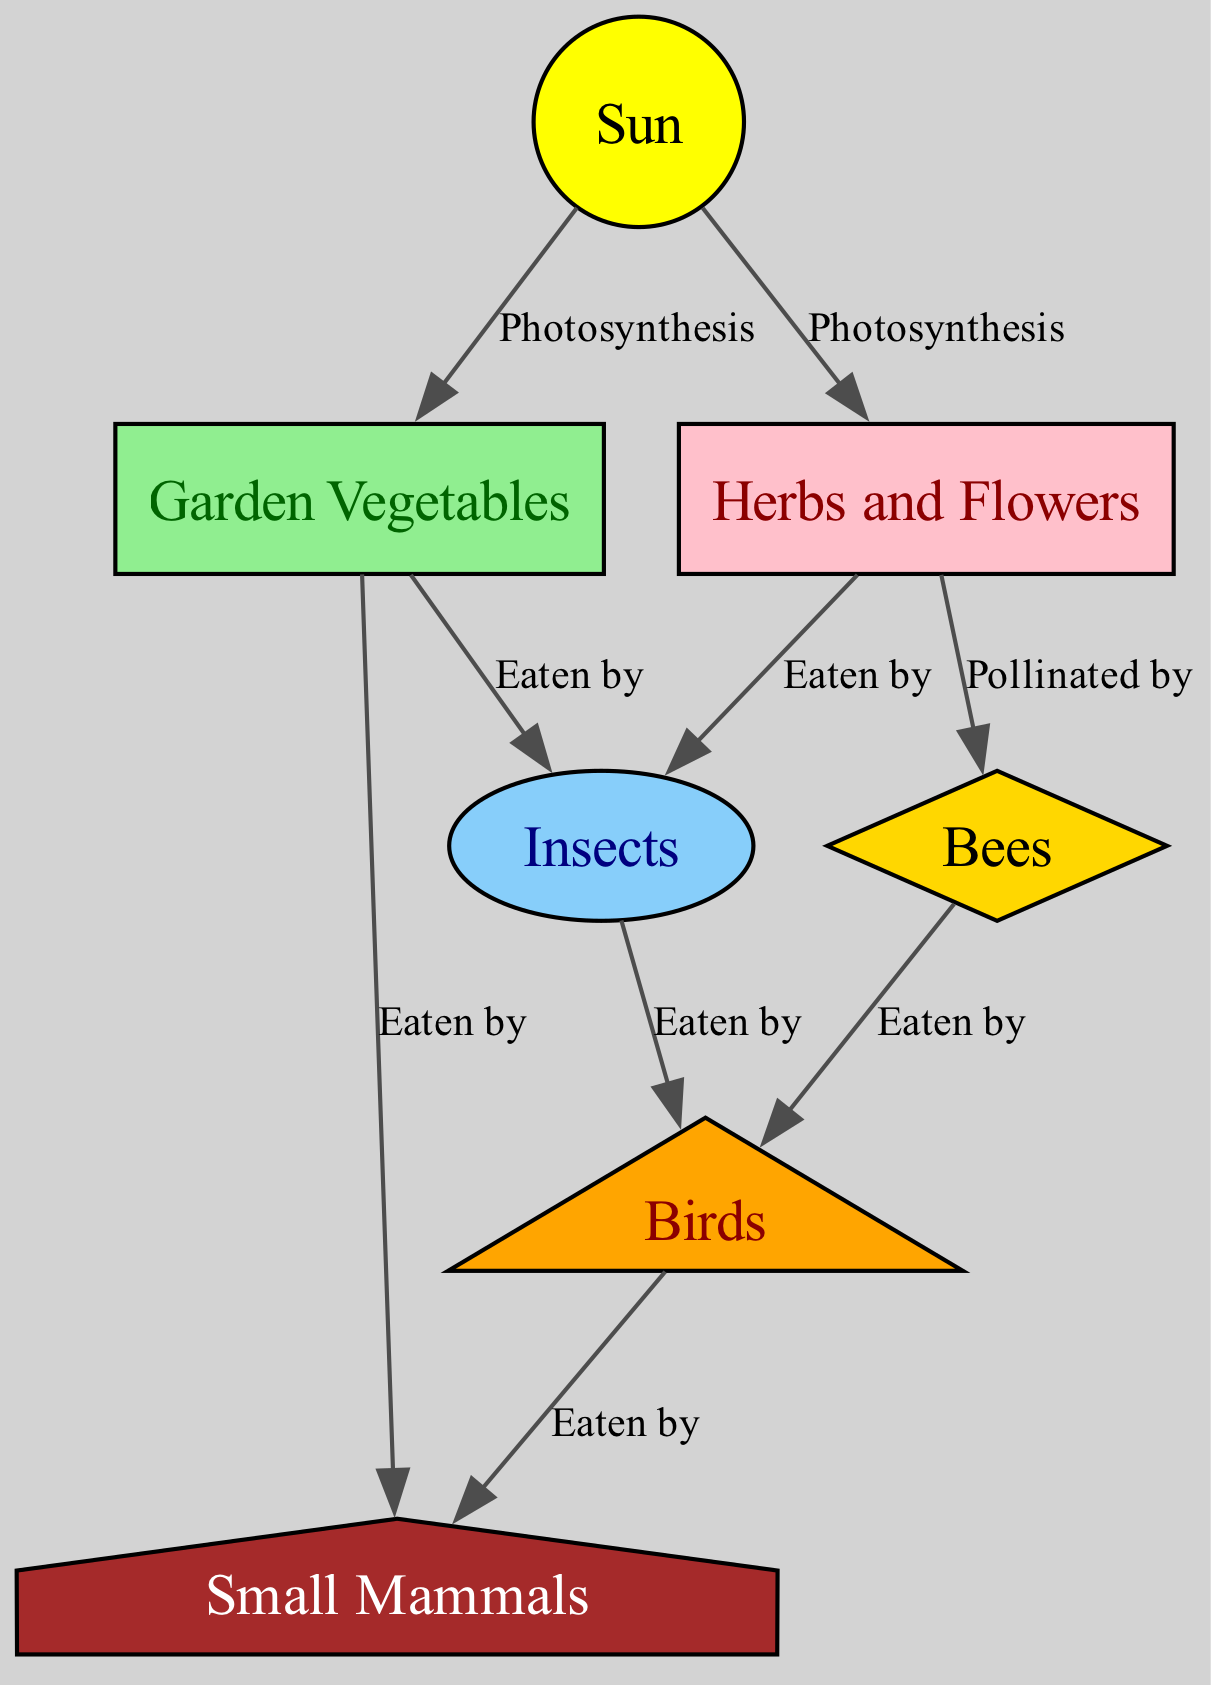What is the source of energy for the food chain? The diagram indicates that the "Sun" is the entry point for energy through "Photosynthesis", which is essential for plants to grow. Hence, the Sun is the primary source of energy for the food chain.
Answer: Sun How many types of nodes are present in the diagram? By examining the nodes listed, there are a total of 7 distinct categories of entities: the Sun, Garden Vegetables, Herbs and Flowers, Insects, Bees, Birds, and Small Mammals. Thus, the total number of types of nodes is 7.
Answer: 7 Which organisms feed on Garden Vegetables? The edges connected to "Garden Vegetables" indicate that Insects and Small Mammals both feed on them, as shown by the labels "Eaten by". Therefore, Insects and Small Mammals consume Garden Vegetables.
Answer: Insects, Small Mammals What role do Bees play in the food chain? According to the edges connected to "Bees", their connection is labeled "Pollinated by" in relation to "Herbs and Flowers". This highlights that Bees have the role of pollinators of these plants.
Answer: Pollinators What is the relationship between Insects and Birds? The diagram illustrates that Insects are "Eaten by" Birds, indicating a predator-prey relationship where Birds consume Insects for nourishment.
Answer: Eaten by How many edges are there in total in the food chain? By counting all the edges listed in the diagram, we see there are 9 connections showing interactions among the nodes. Hence, the total number of edges is 9.
Answer: 9 Which group feeds on the most diverse source of food? Looking at the connections, Birds feed on both Insects and Bees, indicating they have a diverse diet. Therefore, Birds can be considered the group that consumes the most variety of food.
Answer: Birds Which plants are involved in the process of photosynthesis? The diagram shows that both Garden Vegetables and Herbs and Flowers are linked to the Sun with the label "Photosynthesis", indicating that they engage in this process.
Answer: Garden Vegetables, Herbs and Flowers 